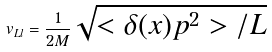<formula> <loc_0><loc_0><loc_500><loc_500>v _ { L l } = \frac { 1 } { 2 M } \sqrt { < \delta ( x ) p ^ { 2 } > / L }</formula> 